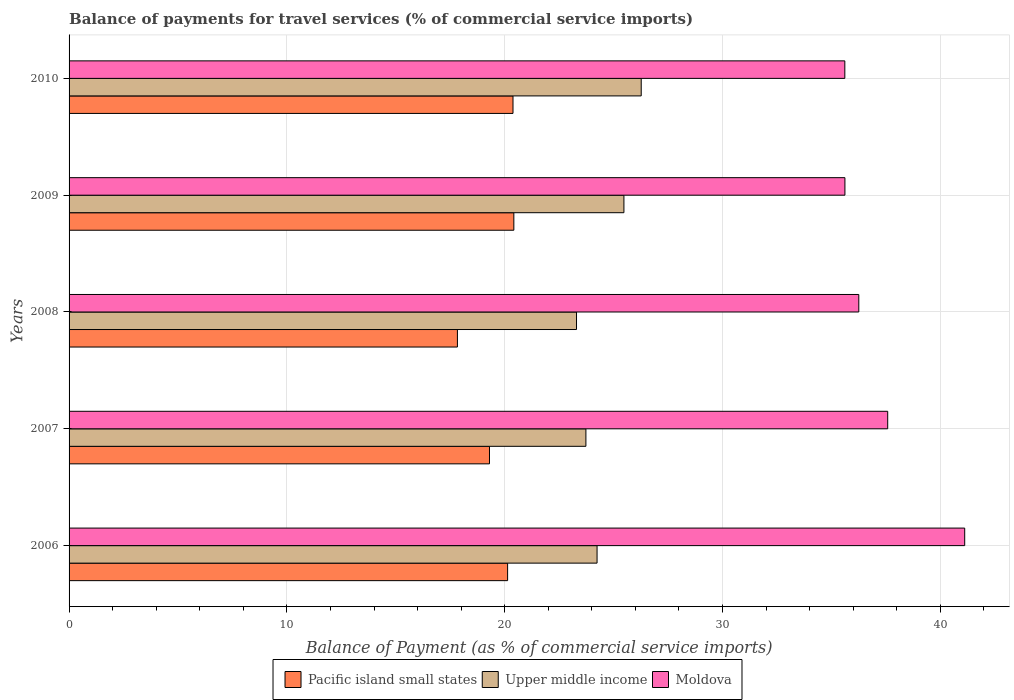How many different coloured bars are there?
Provide a succinct answer. 3. Are the number of bars per tick equal to the number of legend labels?
Offer a very short reply. Yes. Are the number of bars on each tick of the Y-axis equal?
Your answer should be very brief. Yes. What is the label of the 4th group of bars from the top?
Your response must be concise. 2007. What is the balance of payments for travel services in Moldova in 2010?
Provide a short and direct response. 35.61. Across all years, what is the maximum balance of payments for travel services in Pacific island small states?
Offer a very short reply. 20.42. Across all years, what is the minimum balance of payments for travel services in Pacific island small states?
Your answer should be very brief. 17.83. What is the total balance of payments for travel services in Upper middle income in the graph?
Provide a succinct answer. 123. What is the difference between the balance of payments for travel services in Upper middle income in 2006 and that in 2010?
Provide a short and direct response. -2.03. What is the difference between the balance of payments for travel services in Pacific island small states in 2009 and the balance of payments for travel services in Upper middle income in 2008?
Keep it short and to the point. -2.88. What is the average balance of payments for travel services in Moldova per year?
Keep it short and to the point. 37.24. In the year 2006, what is the difference between the balance of payments for travel services in Pacific island small states and balance of payments for travel services in Moldova?
Offer a very short reply. -20.99. What is the ratio of the balance of payments for travel services in Upper middle income in 2007 to that in 2009?
Keep it short and to the point. 0.93. Is the balance of payments for travel services in Moldova in 2006 less than that in 2007?
Your response must be concise. No. What is the difference between the highest and the second highest balance of payments for travel services in Pacific island small states?
Offer a very short reply. 0.04. What is the difference between the highest and the lowest balance of payments for travel services in Pacific island small states?
Your response must be concise. 2.59. In how many years, is the balance of payments for travel services in Pacific island small states greater than the average balance of payments for travel services in Pacific island small states taken over all years?
Make the answer very short. 3. Is the sum of the balance of payments for travel services in Pacific island small states in 2006 and 2007 greater than the maximum balance of payments for travel services in Moldova across all years?
Give a very brief answer. No. What does the 3rd bar from the top in 2007 represents?
Offer a terse response. Pacific island small states. What does the 3rd bar from the bottom in 2010 represents?
Offer a terse response. Moldova. How many bars are there?
Provide a short and direct response. 15. Are the values on the major ticks of X-axis written in scientific E-notation?
Keep it short and to the point. No. Does the graph contain grids?
Your answer should be compact. Yes. Where does the legend appear in the graph?
Your answer should be very brief. Bottom center. What is the title of the graph?
Your response must be concise. Balance of payments for travel services (% of commercial service imports). What is the label or title of the X-axis?
Your answer should be very brief. Balance of Payment (as % of commercial service imports). What is the label or title of the Y-axis?
Ensure brevity in your answer.  Years. What is the Balance of Payment (as % of commercial service imports) in Pacific island small states in 2006?
Your answer should be very brief. 20.13. What is the Balance of Payment (as % of commercial service imports) of Upper middle income in 2006?
Give a very brief answer. 24.24. What is the Balance of Payment (as % of commercial service imports) in Moldova in 2006?
Your answer should be very brief. 41.12. What is the Balance of Payment (as % of commercial service imports) in Pacific island small states in 2007?
Provide a short and direct response. 19.3. What is the Balance of Payment (as % of commercial service imports) in Upper middle income in 2007?
Give a very brief answer. 23.73. What is the Balance of Payment (as % of commercial service imports) in Moldova in 2007?
Your response must be concise. 37.58. What is the Balance of Payment (as % of commercial service imports) in Pacific island small states in 2008?
Provide a short and direct response. 17.83. What is the Balance of Payment (as % of commercial service imports) in Upper middle income in 2008?
Give a very brief answer. 23.3. What is the Balance of Payment (as % of commercial service imports) in Moldova in 2008?
Ensure brevity in your answer.  36.26. What is the Balance of Payment (as % of commercial service imports) in Pacific island small states in 2009?
Provide a short and direct response. 20.42. What is the Balance of Payment (as % of commercial service imports) in Upper middle income in 2009?
Offer a very short reply. 25.47. What is the Balance of Payment (as % of commercial service imports) of Moldova in 2009?
Give a very brief answer. 35.62. What is the Balance of Payment (as % of commercial service imports) of Pacific island small states in 2010?
Your answer should be very brief. 20.38. What is the Balance of Payment (as % of commercial service imports) in Upper middle income in 2010?
Provide a short and direct response. 26.27. What is the Balance of Payment (as % of commercial service imports) of Moldova in 2010?
Your answer should be compact. 35.61. Across all years, what is the maximum Balance of Payment (as % of commercial service imports) of Pacific island small states?
Give a very brief answer. 20.42. Across all years, what is the maximum Balance of Payment (as % of commercial service imports) of Upper middle income?
Offer a terse response. 26.27. Across all years, what is the maximum Balance of Payment (as % of commercial service imports) of Moldova?
Provide a succinct answer. 41.12. Across all years, what is the minimum Balance of Payment (as % of commercial service imports) in Pacific island small states?
Your response must be concise. 17.83. Across all years, what is the minimum Balance of Payment (as % of commercial service imports) in Upper middle income?
Make the answer very short. 23.3. Across all years, what is the minimum Balance of Payment (as % of commercial service imports) in Moldova?
Provide a succinct answer. 35.61. What is the total Balance of Payment (as % of commercial service imports) of Pacific island small states in the graph?
Give a very brief answer. 98.06. What is the total Balance of Payment (as % of commercial service imports) in Upper middle income in the graph?
Make the answer very short. 123. What is the total Balance of Payment (as % of commercial service imports) in Moldova in the graph?
Provide a succinct answer. 186.19. What is the difference between the Balance of Payment (as % of commercial service imports) of Pacific island small states in 2006 and that in 2007?
Offer a very short reply. 0.83. What is the difference between the Balance of Payment (as % of commercial service imports) in Upper middle income in 2006 and that in 2007?
Give a very brief answer. 0.51. What is the difference between the Balance of Payment (as % of commercial service imports) of Moldova in 2006 and that in 2007?
Keep it short and to the point. 3.54. What is the difference between the Balance of Payment (as % of commercial service imports) of Pacific island small states in 2006 and that in 2008?
Your answer should be very brief. 2.3. What is the difference between the Balance of Payment (as % of commercial service imports) of Upper middle income in 2006 and that in 2008?
Give a very brief answer. 0.94. What is the difference between the Balance of Payment (as % of commercial service imports) of Moldova in 2006 and that in 2008?
Provide a short and direct response. 4.86. What is the difference between the Balance of Payment (as % of commercial service imports) in Pacific island small states in 2006 and that in 2009?
Give a very brief answer. -0.29. What is the difference between the Balance of Payment (as % of commercial service imports) of Upper middle income in 2006 and that in 2009?
Provide a succinct answer. -1.23. What is the difference between the Balance of Payment (as % of commercial service imports) of Moldova in 2006 and that in 2009?
Offer a terse response. 5.5. What is the difference between the Balance of Payment (as % of commercial service imports) in Pacific island small states in 2006 and that in 2010?
Ensure brevity in your answer.  -0.25. What is the difference between the Balance of Payment (as % of commercial service imports) of Upper middle income in 2006 and that in 2010?
Offer a very short reply. -2.03. What is the difference between the Balance of Payment (as % of commercial service imports) of Moldova in 2006 and that in 2010?
Ensure brevity in your answer.  5.5. What is the difference between the Balance of Payment (as % of commercial service imports) in Pacific island small states in 2007 and that in 2008?
Keep it short and to the point. 1.47. What is the difference between the Balance of Payment (as % of commercial service imports) in Upper middle income in 2007 and that in 2008?
Your answer should be very brief. 0.43. What is the difference between the Balance of Payment (as % of commercial service imports) in Moldova in 2007 and that in 2008?
Provide a succinct answer. 1.33. What is the difference between the Balance of Payment (as % of commercial service imports) in Pacific island small states in 2007 and that in 2009?
Provide a succinct answer. -1.12. What is the difference between the Balance of Payment (as % of commercial service imports) of Upper middle income in 2007 and that in 2009?
Your answer should be compact. -1.75. What is the difference between the Balance of Payment (as % of commercial service imports) in Moldova in 2007 and that in 2009?
Your response must be concise. 1.96. What is the difference between the Balance of Payment (as % of commercial service imports) in Pacific island small states in 2007 and that in 2010?
Offer a very short reply. -1.08. What is the difference between the Balance of Payment (as % of commercial service imports) of Upper middle income in 2007 and that in 2010?
Ensure brevity in your answer.  -2.54. What is the difference between the Balance of Payment (as % of commercial service imports) in Moldova in 2007 and that in 2010?
Offer a very short reply. 1.97. What is the difference between the Balance of Payment (as % of commercial service imports) of Pacific island small states in 2008 and that in 2009?
Your answer should be compact. -2.59. What is the difference between the Balance of Payment (as % of commercial service imports) in Upper middle income in 2008 and that in 2009?
Your answer should be compact. -2.18. What is the difference between the Balance of Payment (as % of commercial service imports) in Moldova in 2008 and that in 2009?
Provide a short and direct response. 0.64. What is the difference between the Balance of Payment (as % of commercial service imports) of Pacific island small states in 2008 and that in 2010?
Your answer should be compact. -2.55. What is the difference between the Balance of Payment (as % of commercial service imports) of Upper middle income in 2008 and that in 2010?
Offer a terse response. -2.97. What is the difference between the Balance of Payment (as % of commercial service imports) in Moldova in 2008 and that in 2010?
Offer a very short reply. 0.64. What is the difference between the Balance of Payment (as % of commercial service imports) in Pacific island small states in 2009 and that in 2010?
Your answer should be compact. 0.04. What is the difference between the Balance of Payment (as % of commercial service imports) of Upper middle income in 2009 and that in 2010?
Offer a terse response. -0.79. What is the difference between the Balance of Payment (as % of commercial service imports) in Moldova in 2009 and that in 2010?
Make the answer very short. 0. What is the difference between the Balance of Payment (as % of commercial service imports) in Pacific island small states in 2006 and the Balance of Payment (as % of commercial service imports) in Upper middle income in 2007?
Give a very brief answer. -3.59. What is the difference between the Balance of Payment (as % of commercial service imports) in Pacific island small states in 2006 and the Balance of Payment (as % of commercial service imports) in Moldova in 2007?
Offer a terse response. -17.45. What is the difference between the Balance of Payment (as % of commercial service imports) of Upper middle income in 2006 and the Balance of Payment (as % of commercial service imports) of Moldova in 2007?
Offer a terse response. -13.34. What is the difference between the Balance of Payment (as % of commercial service imports) in Pacific island small states in 2006 and the Balance of Payment (as % of commercial service imports) in Upper middle income in 2008?
Keep it short and to the point. -3.16. What is the difference between the Balance of Payment (as % of commercial service imports) in Pacific island small states in 2006 and the Balance of Payment (as % of commercial service imports) in Moldova in 2008?
Your response must be concise. -16.12. What is the difference between the Balance of Payment (as % of commercial service imports) in Upper middle income in 2006 and the Balance of Payment (as % of commercial service imports) in Moldova in 2008?
Provide a succinct answer. -12.02. What is the difference between the Balance of Payment (as % of commercial service imports) in Pacific island small states in 2006 and the Balance of Payment (as % of commercial service imports) in Upper middle income in 2009?
Your answer should be very brief. -5.34. What is the difference between the Balance of Payment (as % of commercial service imports) of Pacific island small states in 2006 and the Balance of Payment (as % of commercial service imports) of Moldova in 2009?
Offer a very short reply. -15.49. What is the difference between the Balance of Payment (as % of commercial service imports) of Upper middle income in 2006 and the Balance of Payment (as % of commercial service imports) of Moldova in 2009?
Your response must be concise. -11.38. What is the difference between the Balance of Payment (as % of commercial service imports) of Pacific island small states in 2006 and the Balance of Payment (as % of commercial service imports) of Upper middle income in 2010?
Your answer should be very brief. -6.13. What is the difference between the Balance of Payment (as % of commercial service imports) of Pacific island small states in 2006 and the Balance of Payment (as % of commercial service imports) of Moldova in 2010?
Ensure brevity in your answer.  -15.48. What is the difference between the Balance of Payment (as % of commercial service imports) of Upper middle income in 2006 and the Balance of Payment (as % of commercial service imports) of Moldova in 2010?
Make the answer very short. -11.38. What is the difference between the Balance of Payment (as % of commercial service imports) in Pacific island small states in 2007 and the Balance of Payment (as % of commercial service imports) in Upper middle income in 2008?
Offer a terse response. -4. What is the difference between the Balance of Payment (as % of commercial service imports) in Pacific island small states in 2007 and the Balance of Payment (as % of commercial service imports) in Moldova in 2008?
Offer a terse response. -16.95. What is the difference between the Balance of Payment (as % of commercial service imports) of Upper middle income in 2007 and the Balance of Payment (as % of commercial service imports) of Moldova in 2008?
Your answer should be compact. -12.53. What is the difference between the Balance of Payment (as % of commercial service imports) of Pacific island small states in 2007 and the Balance of Payment (as % of commercial service imports) of Upper middle income in 2009?
Make the answer very short. -6.17. What is the difference between the Balance of Payment (as % of commercial service imports) of Pacific island small states in 2007 and the Balance of Payment (as % of commercial service imports) of Moldova in 2009?
Your answer should be compact. -16.32. What is the difference between the Balance of Payment (as % of commercial service imports) of Upper middle income in 2007 and the Balance of Payment (as % of commercial service imports) of Moldova in 2009?
Your answer should be compact. -11.89. What is the difference between the Balance of Payment (as % of commercial service imports) in Pacific island small states in 2007 and the Balance of Payment (as % of commercial service imports) in Upper middle income in 2010?
Your answer should be very brief. -6.97. What is the difference between the Balance of Payment (as % of commercial service imports) in Pacific island small states in 2007 and the Balance of Payment (as % of commercial service imports) in Moldova in 2010?
Offer a terse response. -16.31. What is the difference between the Balance of Payment (as % of commercial service imports) of Upper middle income in 2007 and the Balance of Payment (as % of commercial service imports) of Moldova in 2010?
Provide a short and direct response. -11.89. What is the difference between the Balance of Payment (as % of commercial service imports) of Pacific island small states in 2008 and the Balance of Payment (as % of commercial service imports) of Upper middle income in 2009?
Give a very brief answer. -7.64. What is the difference between the Balance of Payment (as % of commercial service imports) of Pacific island small states in 2008 and the Balance of Payment (as % of commercial service imports) of Moldova in 2009?
Offer a terse response. -17.79. What is the difference between the Balance of Payment (as % of commercial service imports) of Upper middle income in 2008 and the Balance of Payment (as % of commercial service imports) of Moldova in 2009?
Provide a succinct answer. -12.32. What is the difference between the Balance of Payment (as % of commercial service imports) of Pacific island small states in 2008 and the Balance of Payment (as % of commercial service imports) of Upper middle income in 2010?
Your answer should be very brief. -8.44. What is the difference between the Balance of Payment (as % of commercial service imports) of Pacific island small states in 2008 and the Balance of Payment (as % of commercial service imports) of Moldova in 2010?
Your answer should be very brief. -17.79. What is the difference between the Balance of Payment (as % of commercial service imports) of Upper middle income in 2008 and the Balance of Payment (as % of commercial service imports) of Moldova in 2010?
Your answer should be very brief. -12.32. What is the difference between the Balance of Payment (as % of commercial service imports) of Pacific island small states in 2009 and the Balance of Payment (as % of commercial service imports) of Upper middle income in 2010?
Make the answer very short. -5.85. What is the difference between the Balance of Payment (as % of commercial service imports) in Pacific island small states in 2009 and the Balance of Payment (as % of commercial service imports) in Moldova in 2010?
Offer a terse response. -15.2. What is the difference between the Balance of Payment (as % of commercial service imports) in Upper middle income in 2009 and the Balance of Payment (as % of commercial service imports) in Moldova in 2010?
Your response must be concise. -10.14. What is the average Balance of Payment (as % of commercial service imports) of Pacific island small states per year?
Your answer should be compact. 19.61. What is the average Balance of Payment (as % of commercial service imports) of Upper middle income per year?
Make the answer very short. 24.6. What is the average Balance of Payment (as % of commercial service imports) in Moldova per year?
Provide a succinct answer. 37.24. In the year 2006, what is the difference between the Balance of Payment (as % of commercial service imports) of Pacific island small states and Balance of Payment (as % of commercial service imports) of Upper middle income?
Keep it short and to the point. -4.11. In the year 2006, what is the difference between the Balance of Payment (as % of commercial service imports) of Pacific island small states and Balance of Payment (as % of commercial service imports) of Moldova?
Ensure brevity in your answer.  -20.99. In the year 2006, what is the difference between the Balance of Payment (as % of commercial service imports) of Upper middle income and Balance of Payment (as % of commercial service imports) of Moldova?
Your answer should be compact. -16.88. In the year 2007, what is the difference between the Balance of Payment (as % of commercial service imports) of Pacific island small states and Balance of Payment (as % of commercial service imports) of Upper middle income?
Offer a terse response. -4.43. In the year 2007, what is the difference between the Balance of Payment (as % of commercial service imports) of Pacific island small states and Balance of Payment (as % of commercial service imports) of Moldova?
Ensure brevity in your answer.  -18.28. In the year 2007, what is the difference between the Balance of Payment (as % of commercial service imports) of Upper middle income and Balance of Payment (as % of commercial service imports) of Moldova?
Keep it short and to the point. -13.86. In the year 2008, what is the difference between the Balance of Payment (as % of commercial service imports) in Pacific island small states and Balance of Payment (as % of commercial service imports) in Upper middle income?
Make the answer very short. -5.47. In the year 2008, what is the difference between the Balance of Payment (as % of commercial service imports) of Pacific island small states and Balance of Payment (as % of commercial service imports) of Moldova?
Your answer should be very brief. -18.43. In the year 2008, what is the difference between the Balance of Payment (as % of commercial service imports) in Upper middle income and Balance of Payment (as % of commercial service imports) in Moldova?
Your response must be concise. -12.96. In the year 2009, what is the difference between the Balance of Payment (as % of commercial service imports) of Pacific island small states and Balance of Payment (as % of commercial service imports) of Upper middle income?
Offer a terse response. -5.05. In the year 2009, what is the difference between the Balance of Payment (as % of commercial service imports) in Pacific island small states and Balance of Payment (as % of commercial service imports) in Moldova?
Your answer should be compact. -15.2. In the year 2009, what is the difference between the Balance of Payment (as % of commercial service imports) in Upper middle income and Balance of Payment (as % of commercial service imports) in Moldova?
Your answer should be compact. -10.15. In the year 2010, what is the difference between the Balance of Payment (as % of commercial service imports) in Pacific island small states and Balance of Payment (as % of commercial service imports) in Upper middle income?
Your answer should be very brief. -5.89. In the year 2010, what is the difference between the Balance of Payment (as % of commercial service imports) in Pacific island small states and Balance of Payment (as % of commercial service imports) in Moldova?
Your answer should be compact. -15.23. In the year 2010, what is the difference between the Balance of Payment (as % of commercial service imports) in Upper middle income and Balance of Payment (as % of commercial service imports) in Moldova?
Your answer should be very brief. -9.35. What is the ratio of the Balance of Payment (as % of commercial service imports) of Pacific island small states in 2006 to that in 2007?
Ensure brevity in your answer.  1.04. What is the ratio of the Balance of Payment (as % of commercial service imports) in Upper middle income in 2006 to that in 2007?
Provide a succinct answer. 1.02. What is the ratio of the Balance of Payment (as % of commercial service imports) in Moldova in 2006 to that in 2007?
Provide a short and direct response. 1.09. What is the ratio of the Balance of Payment (as % of commercial service imports) in Pacific island small states in 2006 to that in 2008?
Offer a terse response. 1.13. What is the ratio of the Balance of Payment (as % of commercial service imports) of Upper middle income in 2006 to that in 2008?
Offer a very short reply. 1.04. What is the ratio of the Balance of Payment (as % of commercial service imports) of Moldova in 2006 to that in 2008?
Your response must be concise. 1.13. What is the ratio of the Balance of Payment (as % of commercial service imports) of Upper middle income in 2006 to that in 2009?
Your answer should be very brief. 0.95. What is the ratio of the Balance of Payment (as % of commercial service imports) of Moldova in 2006 to that in 2009?
Give a very brief answer. 1.15. What is the ratio of the Balance of Payment (as % of commercial service imports) of Pacific island small states in 2006 to that in 2010?
Provide a short and direct response. 0.99. What is the ratio of the Balance of Payment (as % of commercial service imports) in Upper middle income in 2006 to that in 2010?
Provide a succinct answer. 0.92. What is the ratio of the Balance of Payment (as % of commercial service imports) of Moldova in 2006 to that in 2010?
Give a very brief answer. 1.15. What is the ratio of the Balance of Payment (as % of commercial service imports) of Pacific island small states in 2007 to that in 2008?
Keep it short and to the point. 1.08. What is the ratio of the Balance of Payment (as % of commercial service imports) of Upper middle income in 2007 to that in 2008?
Provide a succinct answer. 1.02. What is the ratio of the Balance of Payment (as % of commercial service imports) in Moldova in 2007 to that in 2008?
Your response must be concise. 1.04. What is the ratio of the Balance of Payment (as % of commercial service imports) of Pacific island small states in 2007 to that in 2009?
Offer a very short reply. 0.95. What is the ratio of the Balance of Payment (as % of commercial service imports) of Upper middle income in 2007 to that in 2009?
Offer a terse response. 0.93. What is the ratio of the Balance of Payment (as % of commercial service imports) in Moldova in 2007 to that in 2009?
Make the answer very short. 1.06. What is the ratio of the Balance of Payment (as % of commercial service imports) in Pacific island small states in 2007 to that in 2010?
Ensure brevity in your answer.  0.95. What is the ratio of the Balance of Payment (as % of commercial service imports) of Upper middle income in 2007 to that in 2010?
Provide a succinct answer. 0.9. What is the ratio of the Balance of Payment (as % of commercial service imports) of Moldova in 2007 to that in 2010?
Keep it short and to the point. 1.06. What is the ratio of the Balance of Payment (as % of commercial service imports) of Pacific island small states in 2008 to that in 2009?
Provide a succinct answer. 0.87. What is the ratio of the Balance of Payment (as % of commercial service imports) of Upper middle income in 2008 to that in 2009?
Keep it short and to the point. 0.91. What is the ratio of the Balance of Payment (as % of commercial service imports) in Moldova in 2008 to that in 2009?
Make the answer very short. 1.02. What is the ratio of the Balance of Payment (as % of commercial service imports) of Pacific island small states in 2008 to that in 2010?
Provide a short and direct response. 0.87. What is the ratio of the Balance of Payment (as % of commercial service imports) of Upper middle income in 2008 to that in 2010?
Provide a short and direct response. 0.89. What is the ratio of the Balance of Payment (as % of commercial service imports) in Upper middle income in 2009 to that in 2010?
Your answer should be very brief. 0.97. What is the ratio of the Balance of Payment (as % of commercial service imports) in Moldova in 2009 to that in 2010?
Offer a very short reply. 1. What is the difference between the highest and the second highest Balance of Payment (as % of commercial service imports) of Pacific island small states?
Provide a short and direct response. 0.04. What is the difference between the highest and the second highest Balance of Payment (as % of commercial service imports) in Upper middle income?
Your answer should be compact. 0.79. What is the difference between the highest and the second highest Balance of Payment (as % of commercial service imports) of Moldova?
Your answer should be compact. 3.54. What is the difference between the highest and the lowest Balance of Payment (as % of commercial service imports) in Pacific island small states?
Offer a terse response. 2.59. What is the difference between the highest and the lowest Balance of Payment (as % of commercial service imports) of Upper middle income?
Your response must be concise. 2.97. What is the difference between the highest and the lowest Balance of Payment (as % of commercial service imports) of Moldova?
Provide a succinct answer. 5.5. 